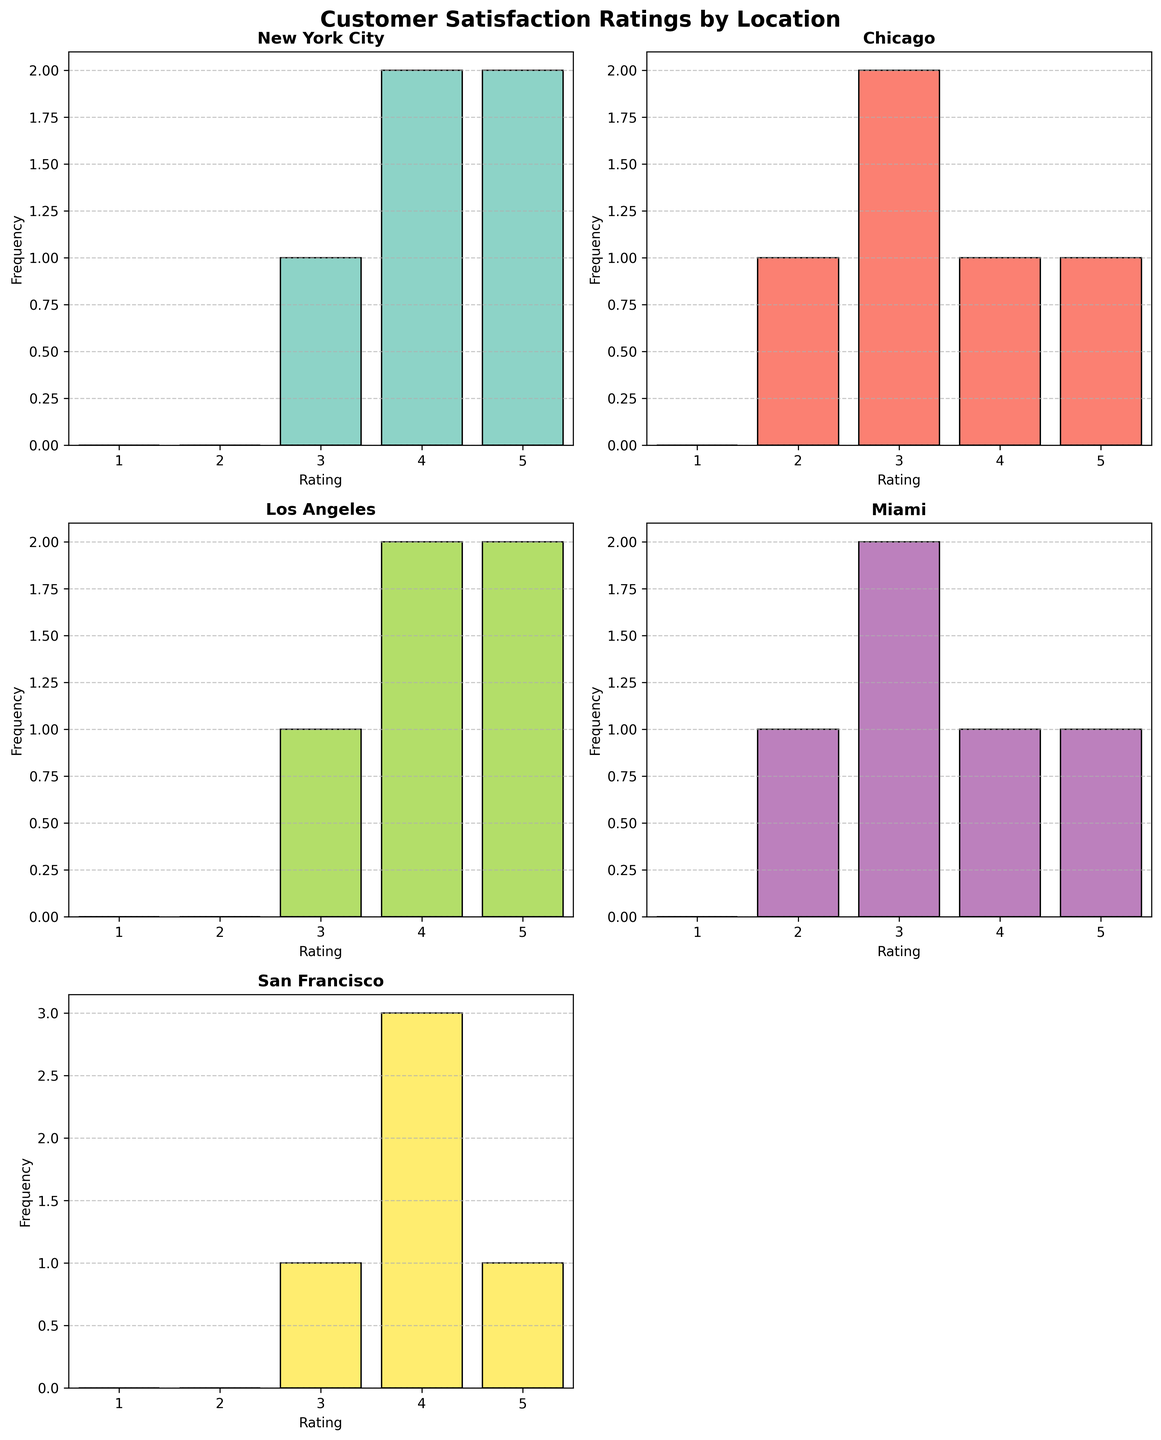What is the title of the figure? The title is displayed at the top of the figure and reads "Customer Satisfaction Ratings by Location". To understand the overall context, reading the title is the first step.
Answer: Customer Satisfaction Ratings by Location How many restaurant locations are shown in the figure? Each subplot represents a different restaurant location. Counting the subplots, we find they correspond to New York City, Chicago, Los Angeles, Miami, and San Francisco.
Answer: 5 What is the most frequent rating for restaurants in Chicago? Observing the histogram for Chicago, we see which bar is the highest, indicating the most frequent rating. The bar for rating 3 is the highest.
Answer: 3 Which location has the highest number of 5-star ratings? By comparing the highest bars for the rating 5 across subplots, we determine that Los Angeles has the tallest bar for 5-star ratings.
Answer: Los Angeles Which location has the least variance in customer satisfaction ratings? We look for the histogram with the most clustered bars around a central rating. San Francisco's ratings are primarily concentrated around 4, showing the least variance.
Answer: San Francisco How many 4-star ratings did Miami receive? By counting the height of the bar corresponding to 4 stars in the Miami subplot, we find this number to be 1.
Answer: 1 Which location's histogram has the widest spread of ratings? We observe each histogram and identify which one has ratings spread out across the most different bars. Miami has ratings spanning from 2 to 5, indicating the widest spread.
Answer: Miami Which rating is missing or not present in the San Francisco subplot? By scanning the histogram bars for San Francisco, we can note if any rating (1 through 5) has no corresponding bar. Rating 1 is absent.
Answer: 1 Are there any locations where the lowest rating given was 3? Checking the minimum rating bars in all histograms, San Francisco and Los Angeles do not have any ratings below 3.
Answer: Yes, San Francisco and Los Angeles What's the difference in the number of 5-star ratings between New York City and Chicago? Counting the 5-star ratings for New York City, which has 2, and Chicago, which also has 1, we calculate the difference by subtracting Chicago's from New York City's.
Answer: 1 